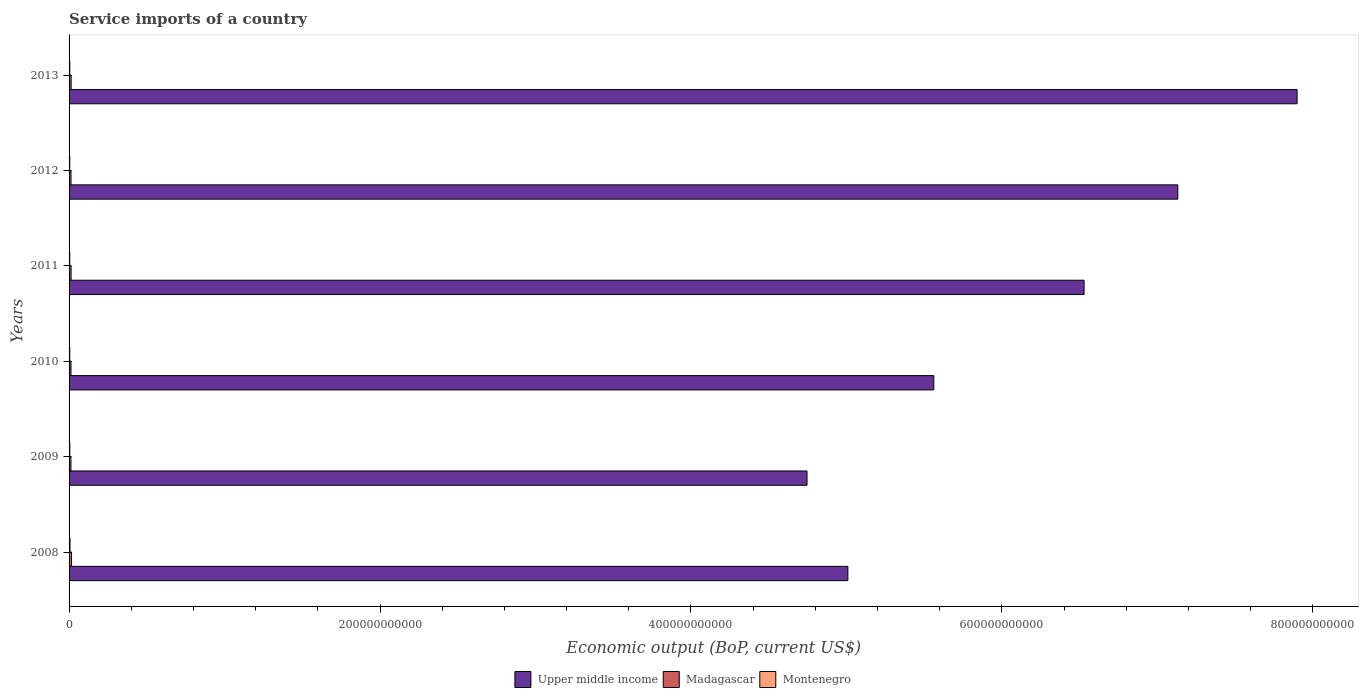How many groups of bars are there?
Ensure brevity in your answer.  6. Are the number of bars on each tick of the Y-axis equal?
Ensure brevity in your answer.  Yes. How many bars are there on the 4th tick from the top?
Provide a short and direct response. 3. How many bars are there on the 6th tick from the bottom?
Give a very brief answer. 3. What is the label of the 6th group of bars from the top?
Offer a terse response. 2008. In how many cases, is the number of bars for a given year not equal to the number of legend labels?
Offer a very short reply. 0. What is the service imports in Madagascar in 2008?
Offer a very short reply. 1.58e+09. Across all years, what is the maximum service imports in Montenegro?
Provide a short and direct response. 6.09e+08. Across all years, what is the minimum service imports in Upper middle income?
Your answer should be very brief. 4.75e+11. In which year was the service imports in Montenegro maximum?
Make the answer very short. 2008. In which year was the service imports in Montenegro minimum?
Offer a terse response. 2011. What is the total service imports in Montenegro in the graph?
Your answer should be very brief. 2.88e+09. What is the difference between the service imports in Upper middle income in 2009 and that in 2010?
Provide a short and direct response. -8.16e+1. What is the difference between the service imports in Montenegro in 2010 and the service imports in Upper middle income in 2013?
Give a very brief answer. -7.89e+11. What is the average service imports in Madagascar per year?
Your answer should be very brief. 1.32e+09. In the year 2009, what is the difference between the service imports in Madagascar and service imports in Montenegro?
Provide a succinct answer. 7.47e+08. In how many years, is the service imports in Upper middle income greater than 160000000000 US$?
Keep it short and to the point. 6. What is the ratio of the service imports in Madagascar in 2008 to that in 2013?
Your answer should be compact. 1.18. Is the service imports in Madagascar in 2008 less than that in 2013?
Offer a very short reply. No. Is the difference between the service imports in Madagascar in 2008 and 2010 greater than the difference between the service imports in Montenegro in 2008 and 2010?
Provide a succinct answer. Yes. What is the difference between the highest and the second highest service imports in Montenegro?
Provide a succinct answer. 1.42e+08. What is the difference between the highest and the lowest service imports in Madagascar?
Your response must be concise. 3.65e+08. Is the sum of the service imports in Montenegro in 2012 and 2013 greater than the maximum service imports in Madagascar across all years?
Give a very brief answer. No. What does the 2nd bar from the top in 2008 represents?
Make the answer very short. Madagascar. What does the 2nd bar from the bottom in 2008 represents?
Keep it short and to the point. Madagascar. Is it the case that in every year, the sum of the service imports in Montenegro and service imports in Upper middle income is greater than the service imports in Madagascar?
Offer a terse response. Yes. Are all the bars in the graph horizontal?
Provide a succinct answer. Yes. How many years are there in the graph?
Keep it short and to the point. 6. What is the difference between two consecutive major ticks on the X-axis?
Offer a very short reply. 2.00e+11. Does the graph contain any zero values?
Your answer should be compact. No. Does the graph contain grids?
Your response must be concise. No. Where does the legend appear in the graph?
Make the answer very short. Bottom center. How are the legend labels stacked?
Ensure brevity in your answer.  Horizontal. What is the title of the graph?
Provide a short and direct response. Service imports of a country. Does "Swaziland" appear as one of the legend labels in the graph?
Offer a very short reply. No. What is the label or title of the X-axis?
Offer a terse response. Economic output (BoP, current US$). What is the label or title of the Y-axis?
Your answer should be very brief. Years. What is the Economic output (BoP, current US$) of Upper middle income in 2008?
Keep it short and to the point. 5.01e+11. What is the Economic output (BoP, current US$) of Madagascar in 2008?
Offer a terse response. 1.58e+09. What is the Economic output (BoP, current US$) in Montenegro in 2008?
Your answer should be compact. 6.09e+08. What is the Economic output (BoP, current US$) of Upper middle income in 2009?
Give a very brief answer. 4.75e+11. What is the Economic output (BoP, current US$) of Madagascar in 2009?
Ensure brevity in your answer.  1.21e+09. What is the Economic output (BoP, current US$) in Montenegro in 2009?
Offer a terse response. 4.67e+08. What is the Economic output (BoP, current US$) in Upper middle income in 2010?
Ensure brevity in your answer.  5.56e+11. What is the Economic output (BoP, current US$) of Madagascar in 2010?
Offer a very short reply. 1.23e+09. What is the Economic output (BoP, current US$) of Montenegro in 2010?
Ensure brevity in your answer.  4.51e+08. What is the Economic output (BoP, current US$) of Upper middle income in 2011?
Your answer should be very brief. 6.53e+11. What is the Economic output (BoP, current US$) in Madagascar in 2011?
Provide a succinct answer. 1.30e+09. What is the Economic output (BoP, current US$) in Montenegro in 2011?
Provide a succinct answer. 4.48e+08. What is the Economic output (BoP, current US$) in Upper middle income in 2012?
Your answer should be compact. 7.13e+11. What is the Economic output (BoP, current US$) in Madagascar in 2012?
Provide a short and direct response. 1.25e+09. What is the Economic output (BoP, current US$) in Montenegro in 2012?
Keep it short and to the point. 4.49e+08. What is the Economic output (BoP, current US$) of Upper middle income in 2013?
Your response must be concise. 7.90e+11. What is the Economic output (BoP, current US$) in Madagascar in 2013?
Your answer should be compact. 1.33e+09. What is the Economic output (BoP, current US$) in Montenegro in 2013?
Ensure brevity in your answer.  4.53e+08. Across all years, what is the maximum Economic output (BoP, current US$) in Upper middle income?
Your answer should be compact. 7.90e+11. Across all years, what is the maximum Economic output (BoP, current US$) in Madagascar?
Make the answer very short. 1.58e+09. Across all years, what is the maximum Economic output (BoP, current US$) in Montenegro?
Your response must be concise. 6.09e+08. Across all years, what is the minimum Economic output (BoP, current US$) of Upper middle income?
Keep it short and to the point. 4.75e+11. Across all years, what is the minimum Economic output (BoP, current US$) in Madagascar?
Keep it short and to the point. 1.21e+09. Across all years, what is the minimum Economic output (BoP, current US$) of Montenegro?
Your response must be concise. 4.48e+08. What is the total Economic output (BoP, current US$) of Upper middle income in the graph?
Your answer should be compact. 3.69e+12. What is the total Economic output (BoP, current US$) in Madagascar in the graph?
Offer a terse response. 7.90e+09. What is the total Economic output (BoP, current US$) of Montenegro in the graph?
Your response must be concise. 2.88e+09. What is the difference between the Economic output (BoP, current US$) in Upper middle income in 2008 and that in 2009?
Keep it short and to the point. 2.63e+1. What is the difference between the Economic output (BoP, current US$) in Madagascar in 2008 and that in 2009?
Offer a terse response. 3.65e+08. What is the difference between the Economic output (BoP, current US$) in Montenegro in 2008 and that in 2009?
Provide a succinct answer. 1.42e+08. What is the difference between the Economic output (BoP, current US$) of Upper middle income in 2008 and that in 2010?
Make the answer very short. -5.53e+1. What is the difference between the Economic output (BoP, current US$) in Madagascar in 2008 and that in 2010?
Provide a short and direct response. 3.53e+08. What is the difference between the Economic output (BoP, current US$) of Montenegro in 2008 and that in 2010?
Make the answer very short. 1.58e+08. What is the difference between the Economic output (BoP, current US$) in Upper middle income in 2008 and that in 2011?
Offer a terse response. -1.52e+11. What is the difference between the Economic output (BoP, current US$) in Madagascar in 2008 and that in 2011?
Your response must be concise. 2.77e+08. What is the difference between the Economic output (BoP, current US$) of Montenegro in 2008 and that in 2011?
Your answer should be very brief. 1.61e+08. What is the difference between the Economic output (BoP, current US$) of Upper middle income in 2008 and that in 2012?
Your answer should be very brief. -2.12e+11. What is the difference between the Economic output (BoP, current US$) of Madagascar in 2008 and that in 2012?
Your response must be concise. 3.34e+08. What is the difference between the Economic output (BoP, current US$) of Montenegro in 2008 and that in 2012?
Your answer should be very brief. 1.60e+08. What is the difference between the Economic output (BoP, current US$) of Upper middle income in 2008 and that in 2013?
Your answer should be compact. -2.89e+11. What is the difference between the Economic output (BoP, current US$) of Madagascar in 2008 and that in 2013?
Ensure brevity in your answer.  2.45e+08. What is the difference between the Economic output (BoP, current US$) in Montenegro in 2008 and that in 2013?
Ensure brevity in your answer.  1.56e+08. What is the difference between the Economic output (BoP, current US$) of Upper middle income in 2009 and that in 2010?
Provide a succinct answer. -8.16e+1. What is the difference between the Economic output (BoP, current US$) of Madagascar in 2009 and that in 2010?
Give a very brief answer. -1.22e+07. What is the difference between the Economic output (BoP, current US$) of Montenegro in 2009 and that in 2010?
Offer a very short reply. 1.63e+07. What is the difference between the Economic output (BoP, current US$) of Upper middle income in 2009 and that in 2011?
Make the answer very short. -1.78e+11. What is the difference between the Economic output (BoP, current US$) of Madagascar in 2009 and that in 2011?
Your answer should be compact. -8.83e+07. What is the difference between the Economic output (BoP, current US$) of Montenegro in 2009 and that in 2011?
Offer a terse response. 1.94e+07. What is the difference between the Economic output (BoP, current US$) of Upper middle income in 2009 and that in 2012?
Offer a terse response. -2.38e+11. What is the difference between the Economic output (BoP, current US$) of Madagascar in 2009 and that in 2012?
Provide a short and direct response. -3.10e+07. What is the difference between the Economic output (BoP, current US$) of Montenegro in 2009 and that in 2012?
Your response must be concise. 1.80e+07. What is the difference between the Economic output (BoP, current US$) of Upper middle income in 2009 and that in 2013?
Give a very brief answer. -3.15e+11. What is the difference between the Economic output (BoP, current US$) of Madagascar in 2009 and that in 2013?
Your answer should be compact. -1.20e+08. What is the difference between the Economic output (BoP, current US$) of Montenegro in 2009 and that in 2013?
Your response must be concise. 1.38e+07. What is the difference between the Economic output (BoP, current US$) in Upper middle income in 2010 and that in 2011?
Keep it short and to the point. -9.66e+1. What is the difference between the Economic output (BoP, current US$) of Madagascar in 2010 and that in 2011?
Offer a very short reply. -7.61e+07. What is the difference between the Economic output (BoP, current US$) of Montenegro in 2010 and that in 2011?
Your answer should be very brief. 3.09e+06. What is the difference between the Economic output (BoP, current US$) of Upper middle income in 2010 and that in 2012?
Your answer should be compact. -1.57e+11. What is the difference between the Economic output (BoP, current US$) of Madagascar in 2010 and that in 2012?
Give a very brief answer. -1.89e+07. What is the difference between the Economic output (BoP, current US$) in Montenegro in 2010 and that in 2012?
Provide a succinct answer. 1.73e+06. What is the difference between the Economic output (BoP, current US$) in Upper middle income in 2010 and that in 2013?
Your answer should be very brief. -2.34e+11. What is the difference between the Economic output (BoP, current US$) of Madagascar in 2010 and that in 2013?
Offer a terse response. -1.08e+08. What is the difference between the Economic output (BoP, current US$) in Montenegro in 2010 and that in 2013?
Make the answer very short. -2.53e+06. What is the difference between the Economic output (BoP, current US$) in Upper middle income in 2011 and that in 2012?
Offer a terse response. -6.03e+1. What is the difference between the Economic output (BoP, current US$) in Madagascar in 2011 and that in 2012?
Keep it short and to the point. 5.73e+07. What is the difference between the Economic output (BoP, current US$) in Montenegro in 2011 and that in 2012?
Your answer should be very brief. -1.36e+06. What is the difference between the Economic output (BoP, current US$) of Upper middle income in 2011 and that in 2013?
Your answer should be very brief. -1.37e+11. What is the difference between the Economic output (BoP, current US$) of Madagascar in 2011 and that in 2013?
Make the answer very short. -3.18e+07. What is the difference between the Economic output (BoP, current US$) in Montenegro in 2011 and that in 2013?
Make the answer very short. -5.62e+06. What is the difference between the Economic output (BoP, current US$) in Upper middle income in 2012 and that in 2013?
Keep it short and to the point. -7.67e+1. What is the difference between the Economic output (BoP, current US$) in Madagascar in 2012 and that in 2013?
Provide a short and direct response. -8.90e+07. What is the difference between the Economic output (BoP, current US$) in Montenegro in 2012 and that in 2013?
Make the answer very short. -4.26e+06. What is the difference between the Economic output (BoP, current US$) of Upper middle income in 2008 and the Economic output (BoP, current US$) of Madagascar in 2009?
Your answer should be compact. 5.00e+11. What is the difference between the Economic output (BoP, current US$) of Upper middle income in 2008 and the Economic output (BoP, current US$) of Montenegro in 2009?
Your answer should be very brief. 5.00e+11. What is the difference between the Economic output (BoP, current US$) in Madagascar in 2008 and the Economic output (BoP, current US$) in Montenegro in 2009?
Provide a short and direct response. 1.11e+09. What is the difference between the Economic output (BoP, current US$) of Upper middle income in 2008 and the Economic output (BoP, current US$) of Madagascar in 2010?
Your answer should be compact. 5.00e+11. What is the difference between the Economic output (BoP, current US$) in Upper middle income in 2008 and the Economic output (BoP, current US$) in Montenegro in 2010?
Provide a short and direct response. 5.00e+11. What is the difference between the Economic output (BoP, current US$) of Madagascar in 2008 and the Economic output (BoP, current US$) of Montenegro in 2010?
Ensure brevity in your answer.  1.13e+09. What is the difference between the Economic output (BoP, current US$) of Upper middle income in 2008 and the Economic output (BoP, current US$) of Madagascar in 2011?
Keep it short and to the point. 5.00e+11. What is the difference between the Economic output (BoP, current US$) of Upper middle income in 2008 and the Economic output (BoP, current US$) of Montenegro in 2011?
Your answer should be very brief. 5.00e+11. What is the difference between the Economic output (BoP, current US$) of Madagascar in 2008 and the Economic output (BoP, current US$) of Montenegro in 2011?
Give a very brief answer. 1.13e+09. What is the difference between the Economic output (BoP, current US$) of Upper middle income in 2008 and the Economic output (BoP, current US$) of Madagascar in 2012?
Offer a terse response. 5.00e+11. What is the difference between the Economic output (BoP, current US$) of Upper middle income in 2008 and the Economic output (BoP, current US$) of Montenegro in 2012?
Offer a terse response. 5.00e+11. What is the difference between the Economic output (BoP, current US$) of Madagascar in 2008 and the Economic output (BoP, current US$) of Montenegro in 2012?
Provide a succinct answer. 1.13e+09. What is the difference between the Economic output (BoP, current US$) of Upper middle income in 2008 and the Economic output (BoP, current US$) of Madagascar in 2013?
Provide a short and direct response. 5.00e+11. What is the difference between the Economic output (BoP, current US$) of Upper middle income in 2008 and the Economic output (BoP, current US$) of Montenegro in 2013?
Ensure brevity in your answer.  5.00e+11. What is the difference between the Economic output (BoP, current US$) of Madagascar in 2008 and the Economic output (BoP, current US$) of Montenegro in 2013?
Your answer should be very brief. 1.13e+09. What is the difference between the Economic output (BoP, current US$) in Upper middle income in 2009 and the Economic output (BoP, current US$) in Madagascar in 2010?
Provide a succinct answer. 4.73e+11. What is the difference between the Economic output (BoP, current US$) in Upper middle income in 2009 and the Economic output (BoP, current US$) in Montenegro in 2010?
Ensure brevity in your answer.  4.74e+11. What is the difference between the Economic output (BoP, current US$) in Madagascar in 2009 and the Economic output (BoP, current US$) in Montenegro in 2010?
Ensure brevity in your answer.  7.63e+08. What is the difference between the Economic output (BoP, current US$) of Upper middle income in 2009 and the Economic output (BoP, current US$) of Madagascar in 2011?
Offer a very short reply. 4.73e+11. What is the difference between the Economic output (BoP, current US$) of Upper middle income in 2009 and the Economic output (BoP, current US$) of Montenegro in 2011?
Provide a succinct answer. 4.74e+11. What is the difference between the Economic output (BoP, current US$) in Madagascar in 2009 and the Economic output (BoP, current US$) in Montenegro in 2011?
Your response must be concise. 7.66e+08. What is the difference between the Economic output (BoP, current US$) of Upper middle income in 2009 and the Economic output (BoP, current US$) of Madagascar in 2012?
Your answer should be compact. 4.73e+11. What is the difference between the Economic output (BoP, current US$) of Upper middle income in 2009 and the Economic output (BoP, current US$) of Montenegro in 2012?
Make the answer very short. 4.74e+11. What is the difference between the Economic output (BoP, current US$) of Madagascar in 2009 and the Economic output (BoP, current US$) of Montenegro in 2012?
Give a very brief answer. 7.65e+08. What is the difference between the Economic output (BoP, current US$) of Upper middle income in 2009 and the Economic output (BoP, current US$) of Madagascar in 2013?
Your answer should be very brief. 4.73e+11. What is the difference between the Economic output (BoP, current US$) of Upper middle income in 2009 and the Economic output (BoP, current US$) of Montenegro in 2013?
Your answer should be compact. 4.74e+11. What is the difference between the Economic output (BoP, current US$) in Madagascar in 2009 and the Economic output (BoP, current US$) in Montenegro in 2013?
Ensure brevity in your answer.  7.61e+08. What is the difference between the Economic output (BoP, current US$) of Upper middle income in 2010 and the Economic output (BoP, current US$) of Madagascar in 2011?
Offer a terse response. 5.55e+11. What is the difference between the Economic output (BoP, current US$) in Upper middle income in 2010 and the Economic output (BoP, current US$) in Montenegro in 2011?
Offer a terse response. 5.56e+11. What is the difference between the Economic output (BoP, current US$) in Madagascar in 2010 and the Economic output (BoP, current US$) in Montenegro in 2011?
Provide a short and direct response. 7.79e+08. What is the difference between the Economic output (BoP, current US$) in Upper middle income in 2010 and the Economic output (BoP, current US$) in Madagascar in 2012?
Keep it short and to the point. 5.55e+11. What is the difference between the Economic output (BoP, current US$) of Upper middle income in 2010 and the Economic output (BoP, current US$) of Montenegro in 2012?
Provide a succinct answer. 5.56e+11. What is the difference between the Economic output (BoP, current US$) of Madagascar in 2010 and the Economic output (BoP, current US$) of Montenegro in 2012?
Ensure brevity in your answer.  7.77e+08. What is the difference between the Economic output (BoP, current US$) of Upper middle income in 2010 and the Economic output (BoP, current US$) of Madagascar in 2013?
Offer a very short reply. 5.55e+11. What is the difference between the Economic output (BoP, current US$) in Upper middle income in 2010 and the Economic output (BoP, current US$) in Montenegro in 2013?
Give a very brief answer. 5.56e+11. What is the difference between the Economic output (BoP, current US$) of Madagascar in 2010 and the Economic output (BoP, current US$) of Montenegro in 2013?
Keep it short and to the point. 7.73e+08. What is the difference between the Economic output (BoP, current US$) in Upper middle income in 2011 and the Economic output (BoP, current US$) in Madagascar in 2012?
Offer a terse response. 6.52e+11. What is the difference between the Economic output (BoP, current US$) of Upper middle income in 2011 and the Economic output (BoP, current US$) of Montenegro in 2012?
Your answer should be very brief. 6.52e+11. What is the difference between the Economic output (BoP, current US$) of Madagascar in 2011 and the Economic output (BoP, current US$) of Montenegro in 2012?
Provide a succinct answer. 8.53e+08. What is the difference between the Economic output (BoP, current US$) in Upper middle income in 2011 and the Economic output (BoP, current US$) in Madagascar in 2013?
Offer a terse response. 6.51e+11. What is the difference between the Economic output (BoP, current US$) of Upper middle income in 2011 and the Economic output (BoP, current US$) of Montenegro in 2013?
Provide a succinct answer. 6.52e+11. What is the difference between the Economic output (BoP, current US$) of Madagascar in 2011 and the Economic output (BoP, current US$) of Montenegro in 2013?
Your answer should be compact. 8.49e+08. What is the difference between the Economic output (BoP, current US$) in Upper middle income in 2012 and the Economic output (BoP, current US$) in Madagascar in 2013?
Provide a succinct answer. 7.12e+11. What is the difference between the Economic output (BoP, current US$) of Upper middle income in 2012 and the Economic output (BoP, current US$) of Montenegro in 2013?
Make the answer very short. 7.13e+11. What is the difference between the Economic output (BoP, current US$) in Madagascar in 2012 and the Economic output (BoP, current US$) in Montenegro in 2013?
Your response must be concise. 7.92e+08. What is the average Economic output (BoP, current US$) of Upper middle income per year?
Ensure brevity in your answer.  6.15e+11. What is the average Economic output (BoP, current US$) in Madagascar per year?
Offer a terse response. 1.32e+09. What is the average Economic output (BoP, current US$) of Montenegro per year?
Provide a short and direct response. 4.79e+08. In the year 2008, what is the difference between the Economic output (BoP, current US$) in Upper middle income and Economic output (BoP, current US$) in Madagascar?
Keep it short and to the point. 4.99e+11. In the year 2008, what is the difference between the Economic output (BoP, current US$) in Upper middle income and Economic output (BoP, current US$) in Montenegro?
Give a very brief answer. 5.00e+11. In the year 2008, what is the difference between the Economic output (BoP, current US$) of Madagascar and Economic output (BoP, current US$) of Montenegro?
Provide a short and direct response. 9.71e+08. In the year 2009, what is the difference between the Economic output (BoP, current US$) in Upper middle income and Economic output (BoP, current US$) in Madagascar?
Provide a short and direct response. 4.73e+11. In the year 2009, what is the difference between the Economic output (BoP, current US$) in Upper middle income and Economic output (BoP, current US$) in Montenegro?
Give a very brief answer. 4.74e+11. In the year 2009, what is the difference between the Economic output (BoP, current US$) of Madagascar and Economic output (BoP, current US$) of Montenegro?
Keep it short and to the point. 7.47e+08. In the year 2010, what is the difference between the Economic output (BoP, current US$) of Upper middle income and Economic output (BoP, current US$) of Madagascar?
Provide a succinct answer. 5.55e+11. In the year 2010, what is the difference between the Economic output (BoP, current US$) in Upper middle income and Economic output (BoP, current US$) in Montenegro?
Keep it short and to the point. 5.56e+11. In the year 2010, what is the difference between the Economic output (BoP, current US$) in Madagascar and Economic output (BoP, current US$) in Montenegro?
Offer a terse response. 7.76e+08. In the year 2011, what is the difference between the Economic output (BoP, current US$) in Upper middle income and Economic output (BoP, current US$) in Madagascar?
Keep it short and to the point. 6.52e+11. In the year 2011, what is the difference between the Economic output (BoP, current US$) of Upper middle income and Economic output (BoP, current US$) of Montenegro?
Your answer should be very brief. 6.52e+11. In the year 2011, what is the difference between the Economic output (BoP, current US$) in Madagascar and Economic output (BoP, current US$) in Montenegro?
Your answer should be very brief. 8.55e+08. In the year 2012, what is the difference between the Economic output (BoP, current US$) of Upper middle income and Economic output (BoP, current US$) of Madagascar?
Offer a terse response. 7.12e+11. In the year 2012, what is the difference between the Economic output (BoP, current US$) in Upper middle income and Economic output (BoP, current US$) in Montenegro?
Your answer should be very brief. 7.13e+11. In the year 2012, what is the difference between the Economic output (BoP, current US$) of Madagascar and Economic output (BoP, current US$) of Montenegro?
Offer a terse response. 7.96e+08. In the year 2013, what is the difference between the Economic output (BoP, current US$) of Upper middle income and Economic output (BoP, current US$) of Madagascar?
Make the answer very short. 7.88e+11. In the year 2013, what is the difference between the Economic output (BoP, current US$) in Upper middle income and Economic output (BoP, current US$) in Montenegro?
Offer a very short reply. 7.89e+11. In the year 2013, what is the difference between the Economic output (BoP, current US$) in Madagascar and Economic output (BoP, current US$) in Montenegro?
Provide a succinct answer. 8.81e+08. What is the ratio of the Economic output (BoP, current US$) in Upper middle income in 2008 to that in 2009?
Provide a succinct answer. 1.06. What is the ratio of the Economic output (BoP, current US$) in Madagascar in 2008 to that in 2009?
Ensure brevity in your answer.  1.3. What is the ratio of the Economic output (BoP, current US$) of Montenegro in 2008 to that in 2009?
Ensure brevity in your answer.  1.3. What is the ratio of the Economic output (BoP, current US$) of Upper middle income in 2008 to that in 2010?
Provide a succinct answer. 0.9. What is the ratio of the Economic output (BoP, current US$) in Madagascar in 2008 to that in 2010?
Ensure brevity in your answer.  1.29. What is the ratio of the Economic output (BoP, current US$) of Montenegro in 2008 to that in 2010?
Offer a terse response. 1.35. What is the ratio of the Economic output (BoP, current US$) in Upper middle income in 2008 to that in 2011?
Provide a succinct answer. 0.77. What is the ratio of the Economic output (BoP, current US$) in Madagascar in 2008 to that in 2011?
Offer a very short reply. 1.21. What is the ratio of the Economic output (BoP, current US$) in Montenegro in 2008 to that in 2011?
Ensure brevity in your answer.  1.36. What is the ratio of the Economic output (BoP, current US$) in Upper middle income in 2008 to that in 2012?
Your response must be concise. 0.7. What is the ratio of the Economic output (BoP, current US$) in Madagascar in 2008 to that in 2012?
Provide a succinct answer. 1.27. What is the ratio of the Economic output (BoP, current US$) in Montenegro in 2008 to that in 2012?
Your response must be concise. 1.36. What is the ratio of the Economic output (BoP, current US$) of Upper middle income in 2008 to that in 2013?
Keep it short and to the point. 0.63. What is the ratio of the Economic output (BoP, current US$) in Madagascar in 2008 to that in 2013?
Offer a very short reply. 1.18. What is the ratio of the Economic output (BoP, current US$) of Montenegro in 2008 to that in 2013?
Provide a short and direct response. 1.34. What is the ratio of the Economic output (BoP, current US$) in Upper middle income in 2009 to that in 2010?
Make the answer very short. 0.85. What is the ratio of the Economic output (BoP, current US$) in Montenegro in 2009 to that in 2010?
Offer a terse response. 1.04. What is the ratio of the Economic output (BoP, current US$) of Upper middle income in 2009 to that in 2011?
Your answer should be compact. 0.73. What is the ratio of the Economic output (BoP, current US$) of Madagascar in 2009 to that in 2011?
Make the answer very short. 0.93. What is the ratio of the Economic output (BoP, current US$) in Montenegro in 2009 to that in 2011?
Provide a succinct answer. 1.04. What is the ratio of the Economic output (BoP, current US$) of Upper middle income in 2009 to that in 2012?
Offer a very short reply. 0.67. What is the ratio of the Economic output (BoP, current US$) in Madagascar in 2009 to that in 2012?
Provide a short and direct response. 0.98. What is the ratio of the Economic output (BoP, current US$) in Montenegro in 2009 to that in 2012?
Provide a short and direct response. 1.04. What is the ratio of the Economic output (BoP, current US$) of Upper middle income in 2009 to that in 2013?
Keep it short and to the point. 0.6. What is the ratio of the Economic output (BoP, current US$) in Madagascar in 2009 to that in 2013?
Provide a short and direct response. 0.91. What is the ratio of the Economic output (BoP, current US$) of Montenegro in 2009 to that in 2013?
Your response must be concise. 1.03. What is the ratio of the Economic output (BoP, current US$) in Upper middle income in 2010 to that in 2011?
Your answer should be very brief. 0.85. What is the ratio of the Economic output (BoP, current US$) of Madagascar in 2010 to that in 2011?
Your answer should be compact. 0.94. What is the ratio of the Economic output (BoP, current US$) in Montenegro in 2010 to that in 2011?
Ensure brevity in your answer.  1.01. What is the ratio of the Economic output (BoP, current US$) in Upper middle income in 2010 to that in 2012?
Provide a short and direct response. 0.78. What is the ratio of the Economic output (BoP, current US$) in Madagascar in 2010 to that in 2012?
Ensure brevity in your answer.  0.98. What is the ratio of the Economic output (BoP, current US$) of Montenegro in 2010 to that in 2012?
Provide a short and direct response. 1. What is the ratio of the Economic output (BoP, current US$) of Upper middle income in 2010 to that in 2013?
Ensure brevity in your answer.  0.7. What is the ratio of the Economic output (BoP, current US$) in Madagascar in 2010 to that in 2013?
Your answer should be very brief. 0.92. What is the ratio of the Economic output (BoP, current US$) of Montenegro in 2010 to that in 2013?
Ensure brevity in your answer.  0.99. What is the ratio of the Economic output (BoP, current US$) of Upper middle income in 2011 to that in 2012?
Offer a very short reply. 0.92. What is the ratio of the Economic output (BoP, current US$) in Madagascar in 2011 to that in 2012?
Offer a terse response. 1.05. What is the ratio of the Economic output (BoP, current US$) in Montenegro in 2011 to that in 2012?
Keep it short and to the point. 1. What is the ratio of the Economic output (BoP, current US$) in Upper middle income in 2011 to that in 2013?
Offer a terse response. 0.83. What is the ratio of the Economic output (BoP, current US$) in Madagascar in 2011 to that in 2013?
Make the answer very short. 0.98. What is the ratio of the Economic output (BoP, current US$) in Montenegro in 2011 to that in 2013?
Your response must be concise. 0.99. What is the ratio of the Economic output (BoP, current US$) of Upper middle income in 2012 to that in 2013?
Offer a very short reply. 0.9. What is the ratio of the Economic output (BoP, current US$) in Madagascar in 2012 to that in 2013?
Provide a short and direct response. 0.93. What is the ratio of the Economic output (BoP, current US$) in Montenegro in 2012 to that in 2013?
Your answer should be compact. 0.99. What is the difference between the highest and the second highest Economic output (BoP, current US$) of Upper middle income?
Your answer should be very brief. 7.67e+1. What is the difference between the highest and the second highest Economic output (BoP, current US$) of Madagascar?
Your answer should be very brief. 2.45e+08. What is the difference between the highest and the second highest Economic output (BoP, current US$) in Montenegro?
Offer a terse response. 1.42e+08. What is the difference between the highest and the lowest Economic output (BoP, current US$) in Upper middle income?
Your answer should be compact. 3.15e+11. What is the difference between the highest and the lowest Economic output (BoP, current US$) of Madagascar?
Provide a short and direct response. 3.65e+08. What is the difference between the highest and the lowest Economic output (BoP, current US$) in Montenegro?
Offer a very short reply. 1.61e+08. 